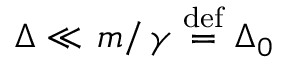Convert formula to latex. <formula><loc_0><loc_0><loc_500><loc_500>\begin{array} { r } { \Delta \ll m \right / \gamma \stackrel { d e f } { = } \Delta _ { 0 } } \end{array}</formula> 